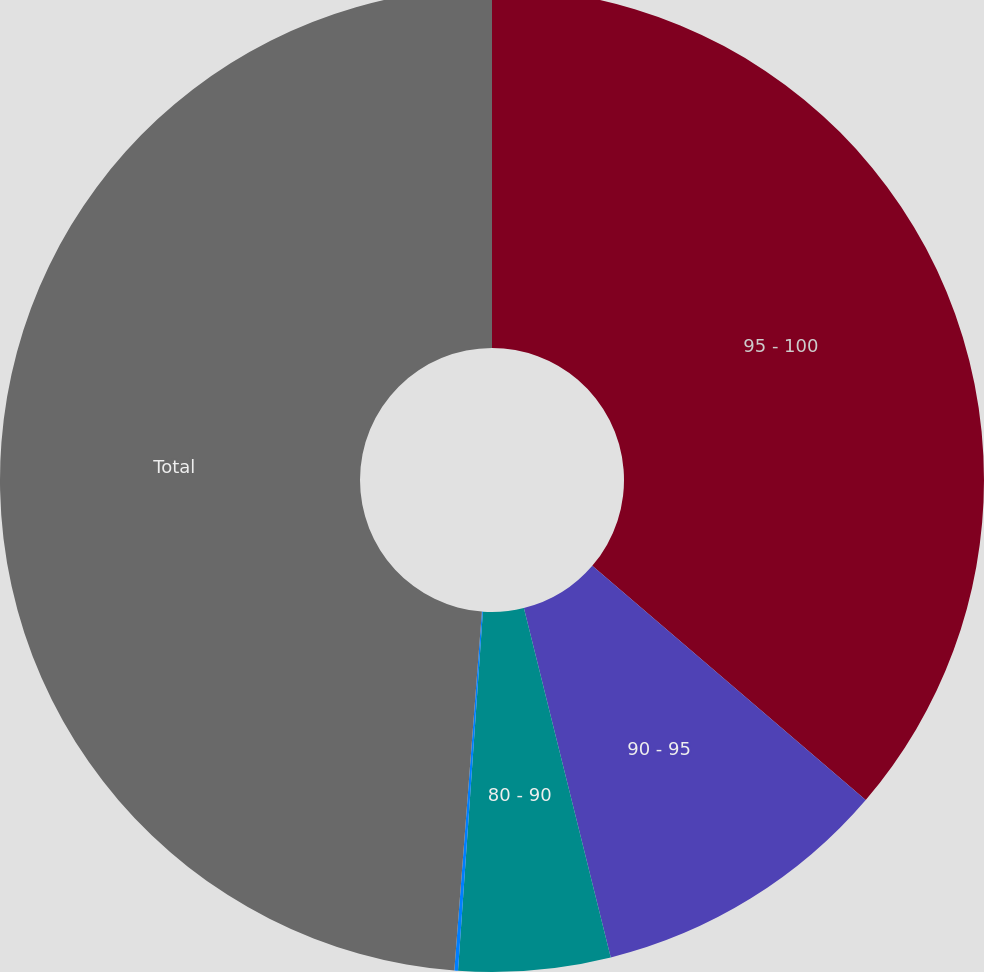Convert chart to OTSL. <chart><loc_0><loc_0><loc_500><loc_500><pie_chart><fcel>95 - 100<fcel>90 - 95<fcel>80 - 90<fcel>Less than 80<fcel>Total<nl><fcel>36.27%<fcel>9.85%<fcel>4.98%<fcel>0.12%<fcel>48.78%<nl></chart> 